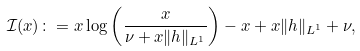<formula> <loc_0><loc_0><loc_500><loc_500>\mathcal { I } ( x ) \colon = x \log \left ( \frac { x } { \nu + x \| h \| _ { L ^ { 1 } } } \right ) - x + x \| h \| _ { L ^ { 1 } } + \nu ,</formula> 